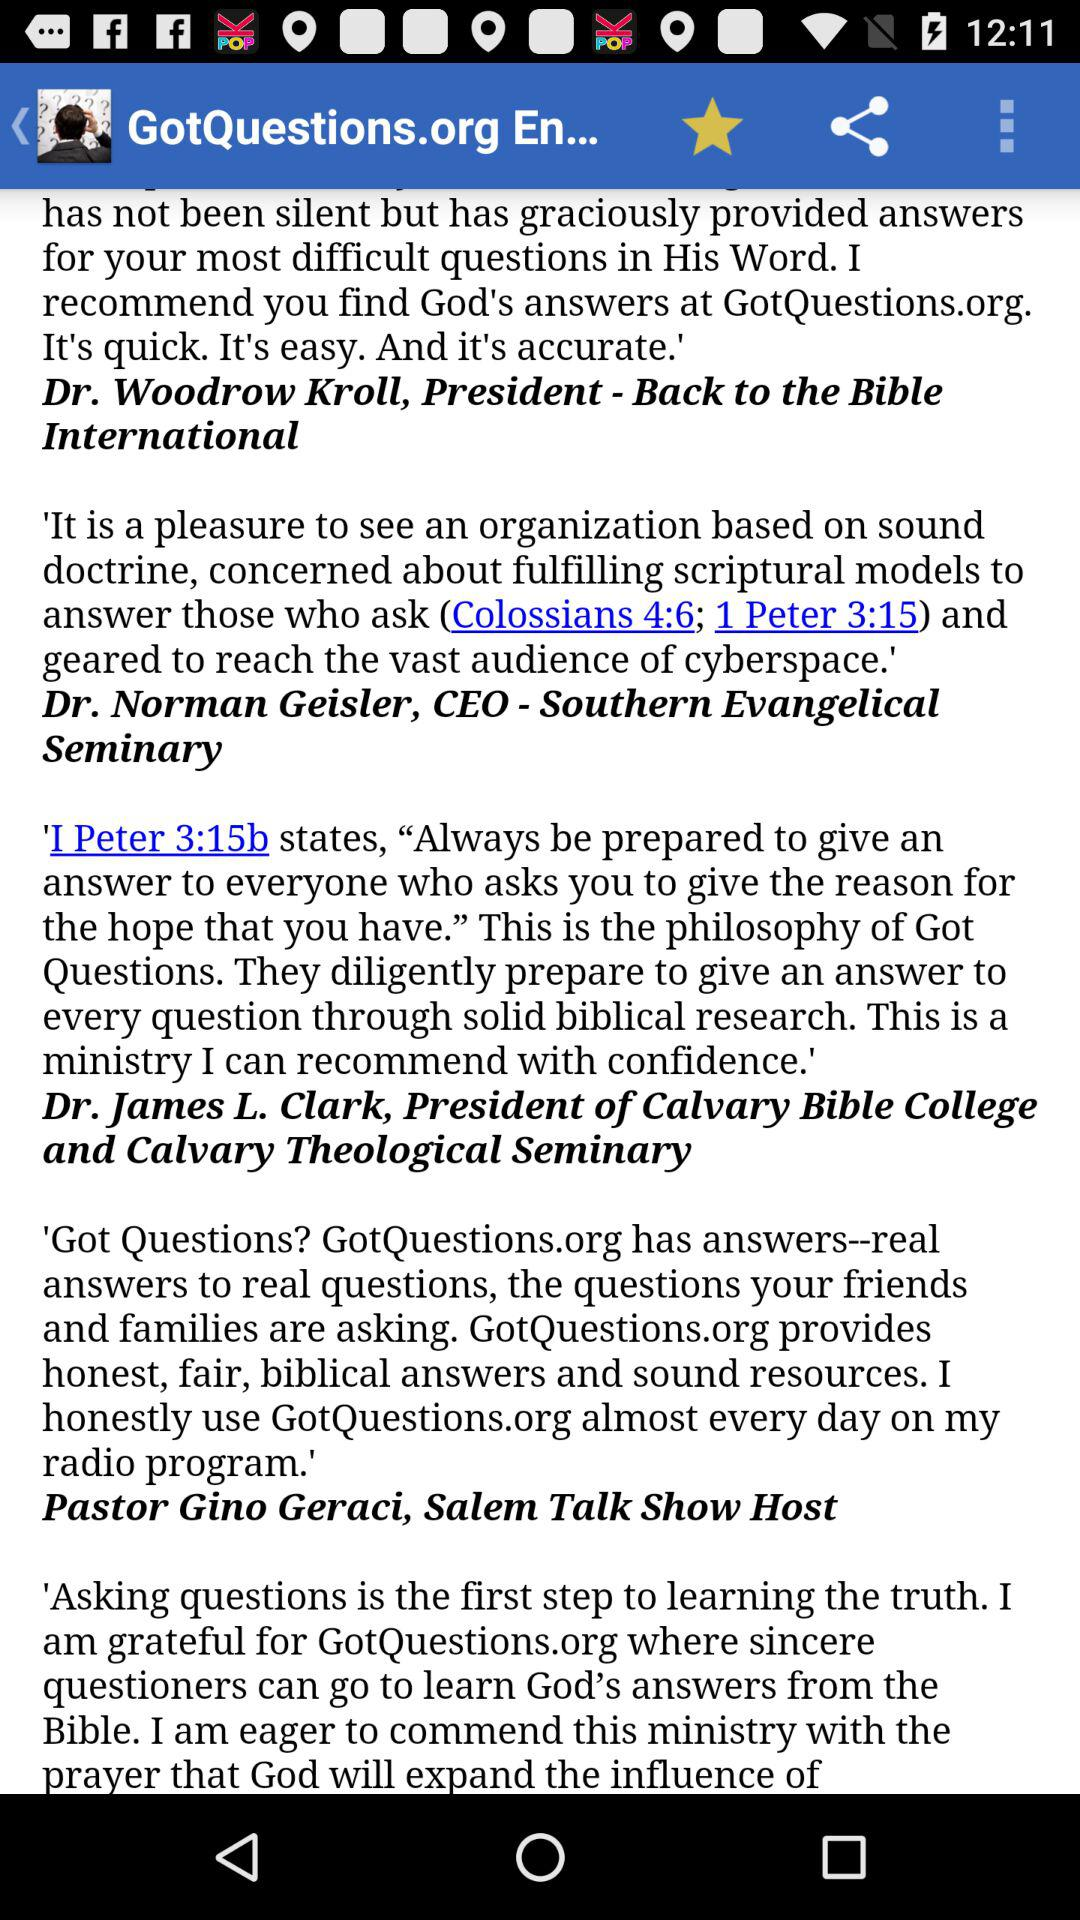Who is the CEO of "Southern Evangelical Seminary"? The CEO is "Dr. Norman Geisler". 